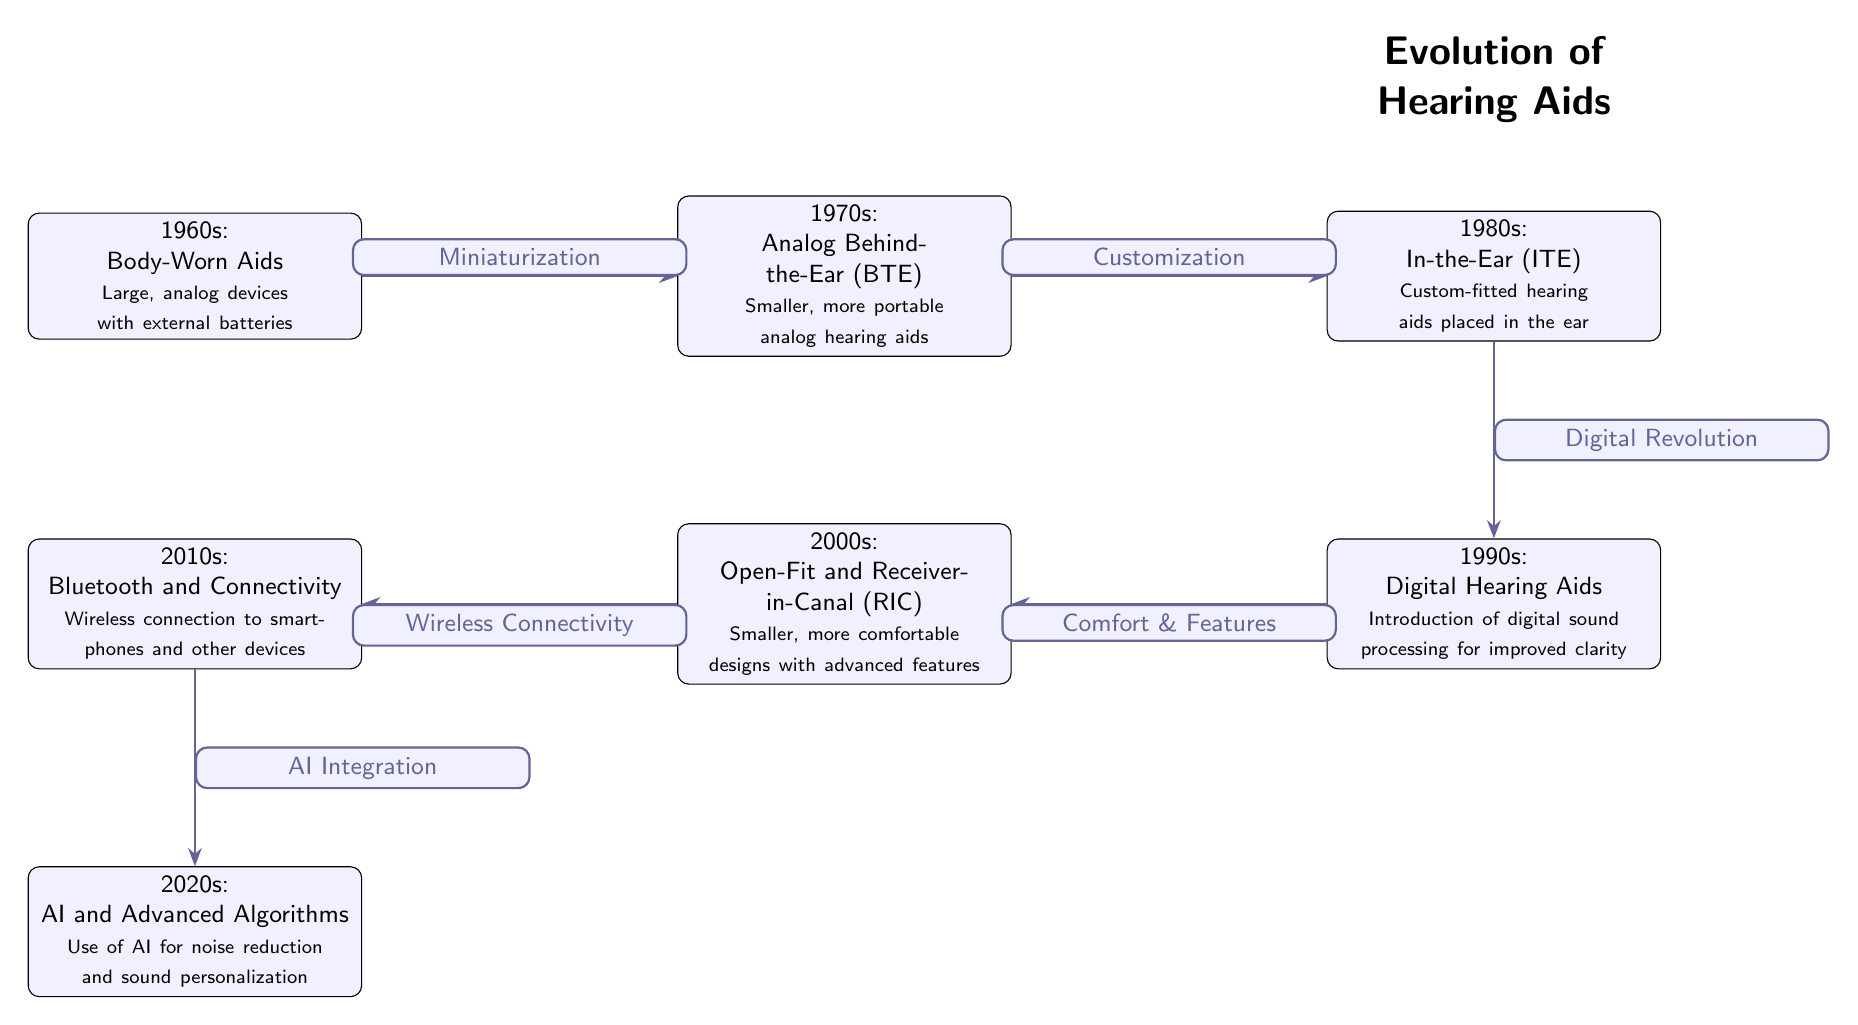What's the first invention shown in the diagram? The diagram starts with "1960s: Body-Worn Aids" as the first node, indicating the earliest technology highlighted in the progression of hearing aids.
Answer: Body-Worn Aids How many advancements are shown in the diagram? The diagram lists advancements from the 1960s to the 2020s, which amounts to a total of seven nodes: one for each decade.
Answer: 7 Which decade saw the introduction of digital sound processing? The "1990s: Digital Hearing Aids" node explicitly mentions the introduction of digital sound processing, marking it as the relevant decade for this advancement.
Answer: 1990s What advancement leads to the use of AI for sound personalization? The diagram indicates that "2010s: Bluetooth and Connectivity" leads to "2020s: AI and Advanced Algorithms," establishing the pathway toward the use of AI in hearing aids.
Answer: Bluetooth and Connectivity What is the relationship between the 1980s and the 1990s in the diagram? The arrow from the "1980s: In-the-Ear (ITE)" node to the "1990s: Digital Hearing Aids" node is labeled "Digital Revolution," indicating a significant shift that connects the advancements of these two decades.
Answer: Digital Revolution Which two advancements improved comfort and features in hearing aids? The diagram connects "1990s: Digital Hearing Aids" to "2000s: Open-Fit and Receiver-in-Canal (RIC)" with an edge labeled "Comfort & Features," implying these advancements contributed to improved user comfort and features.
Answer: Digital Hearing Aids, Open-Fit and Receiver-in-Canal (RIC) How is miniaturization depicted in this diagram? Miniaturization is seen through the progression arrows starting from "1960s: Body-Worn Aids" to "1970s: Analog Behind-the-Ear (BTE)," illustrating a move towards smaller devices over the decades.
Answer: Miniaturization What is a significant technological factor that links the 2000s to the 2010s? The edge labeled "Wireless Connectivity" connects the "2000s: Open-Fit and Receiver-in-Canal (RIC)" node to the "2010s: Bluetooth and Connectivity" node, signifying a major technological progression between these two advancements.
Answer: Wireless Connectivity 